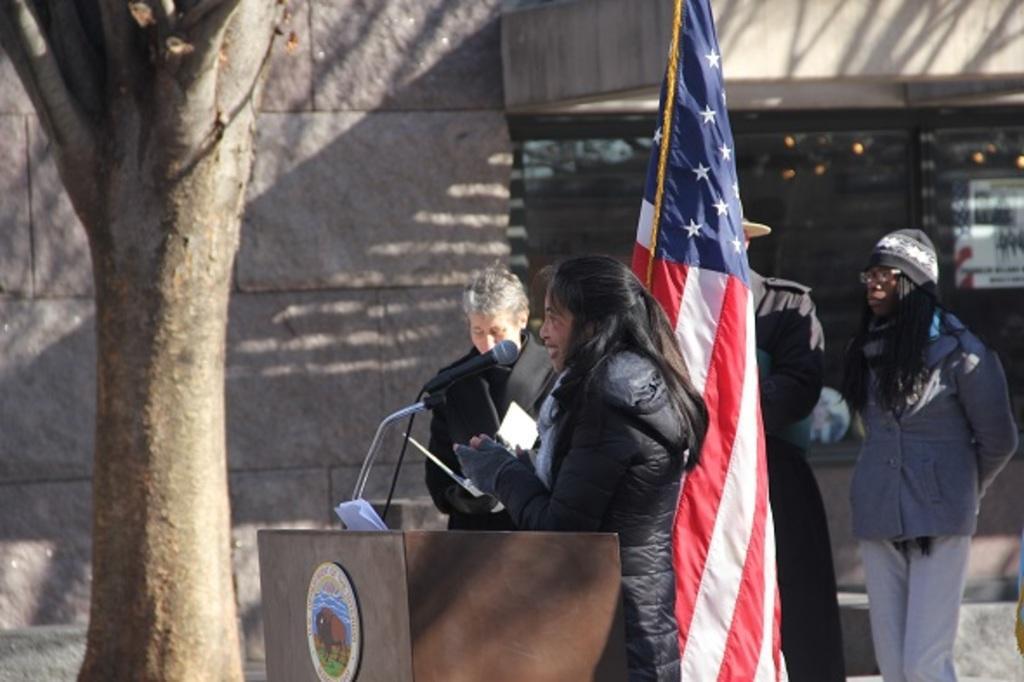Could you give a brief overview of what you see in this image? There is a person in black color jacket, smiling and standing in front of a stand on which, there is a mic attached to the stand. On the left side, there is a tree. In the background, there are persons standing, there is a flag and there is a building. 